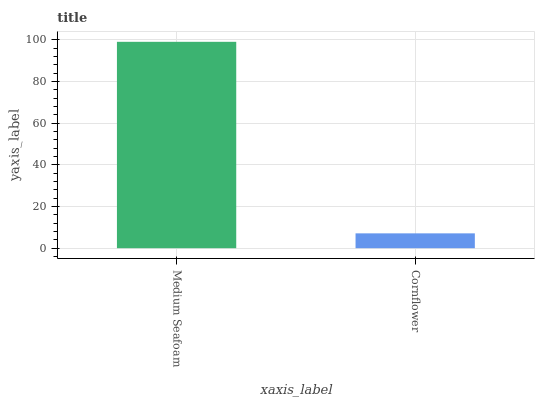Is Cornflower the minimum?
Answer yes or no. Yes. Is Medium Seafoam the maximum?
Answer yes or no. Yes. Is Cornflower the maximum?
Answer yes or no. No. Is Medium Seafoam greater than Cornflower?
Answer yes or no. Yes. Is Cornflower less than Medium Seafoam?
Answer yes or no. Yes. Is Cornflower greater than Medium Seafoam?
Answer yes or no. No. Is Medium Seafoam less than Cornflower?
Answer yes or no. No. Is Medium Seafoam the high median?
Answer yes or no. Yes. Is Cornflower the low median?
Answer yes or no. Yes. Is Cornflower the high median?
Answer yes or no. No. Is Medium Seafoam the low median?
Answer yes or no. No. 